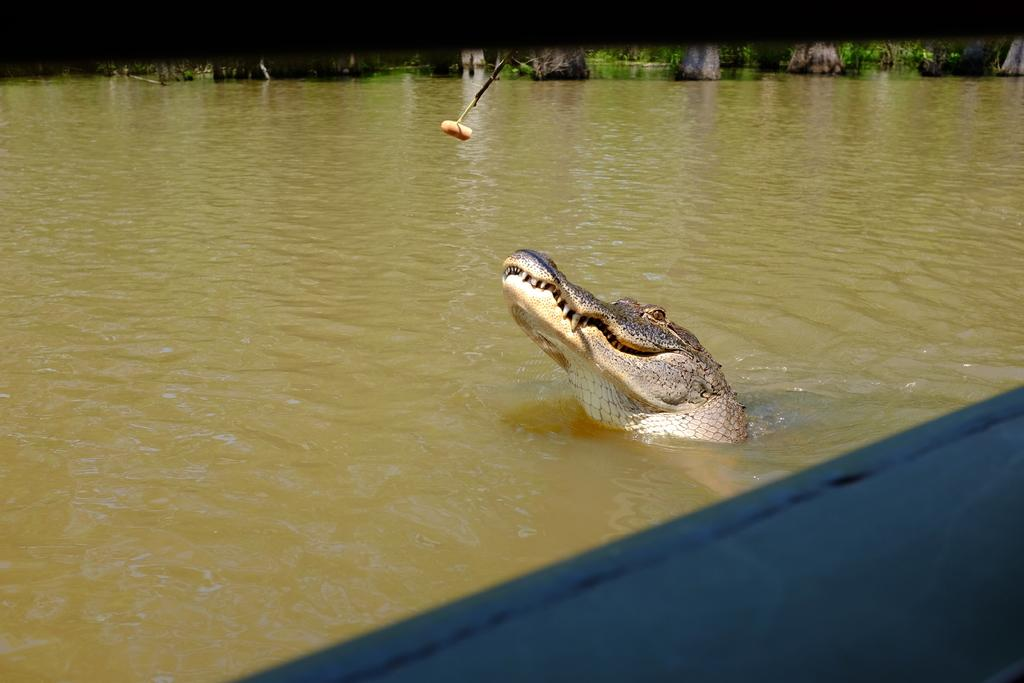What animal can be seen in the water in the image? There is a crocodile in the water in the image. What object is visible in the image besides the crocodile? There is a stick visible in the image. What type of vegetation is present in the image? There are trees present in the image. What type of eggnog is being consumed by the group in the image? There is no group or eggnog present in the image; it features a crocodile in the water and a stick. What is the crocodile's state of mind in the image? The image does not provide information about the crocodile's state of mind; it only shows the crocodile in the water and a stick. 